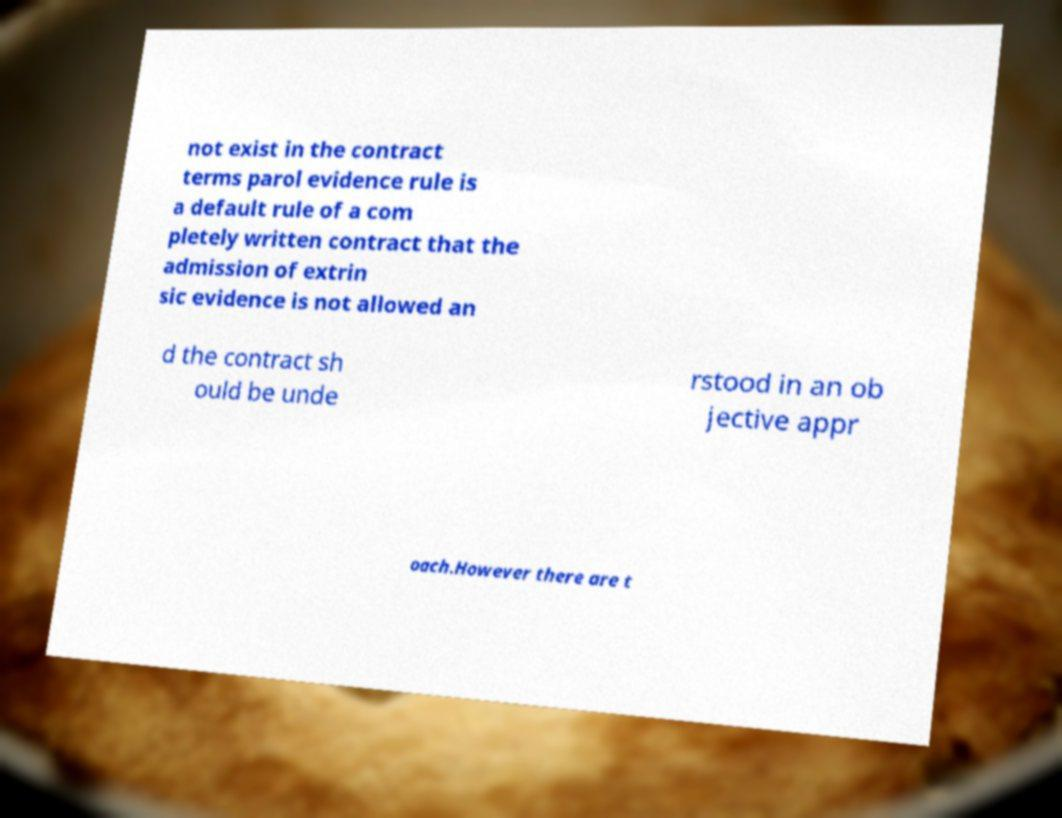I need the written content from this picture converted into text. Can you do that? not exist in the contract terms parol evidence rule is a default rule of a com pletely written contract that the admission of extrin sic evidence is not allowed an d the contract sh ould be unde rstood in an ob jective appr oach.However there are t 